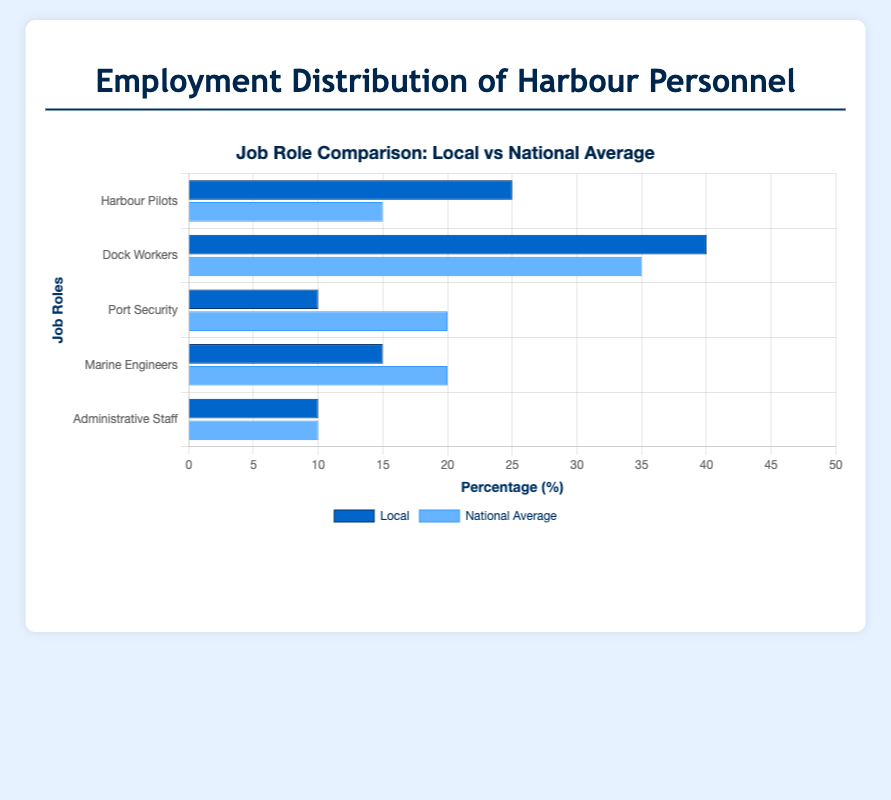Which job role has the highest local employment percentage? By looking at the heights of the blue bars for each job role on the horizontal grouped bar chart, we see that the Dock Workers have the highest local employment percentage with a bar reaching 40%.
Answer: Dock Workers Which job role shows a greater local employment percentage compared to the national average for Marine Engineers? Compare the blue bar for Marine Engineers (15%) with the national average bar for the same role (20%). The blue bar is shorter, indicating that the local percentage is less than the national average.
Answer: Harbour Pilots How much higher is the local employment percentage for Harbour Pilots compared to the national average? The local employment percentage for Harbour Pilots is 25%, and the national average is 15%, so the difference is calculated as 25% - 15% = 10%.
Answer: 10% What is the sum of the local employment percentages for Port Security and Administrative Staff? Add the local employment percentages for Port Security (10%) and Administrative Staff (10%). Sum = 10% + 10% = 20%.
Answer: 20% Which job role has an equal local employment percentage and national average? Identify the job roles where the blue and light blue bars are of equal height. The Administrative Staff role shows both local and national bars reaching 10%.
Answer: Administrative Staff Are there any job roles where the local employment percentage is less than the national average? Check the heights of the blue bars against the light blue bars for each job role. The job roles where the blue bar is shorter than the light blue bar are Port Security (10% local vs. 20% national) and Marine Engineers (15% local vs. 20% national).
Answer: Yes What is the average national employment percentage for all job roles? Sum the national employment percentages (15% + 35% + 20% + 20% + 10%) = 100%. Then, divide by the number of job rows (5). Average = 100% / 5 = 20%.
Answer: 20% What is the difference in percentage points between the local and national average employment for Dock Workers? Local employment for Dock Workers is 40% and the national average is 35%. The difference is 40% - 35% = 5%.
Answer: 5% By how many percentage points does the local employment percentage for Harbour Pilots exceed that of Marine Engineers? Harbour Pilots have a local employment percentage of 25% and Marine Engineers have 15%. The difference is 25% - 15% = 10%.
Answer: 10% Which job roles have a local employment percentage higher than the national average? Compare the local and national average percentages for each job role. Those with higher local employment are Harbour Pilots (25% > 15%) and Dock Workers (40% > 35%).
Answer: Harbour Pilots, Dock Workers 